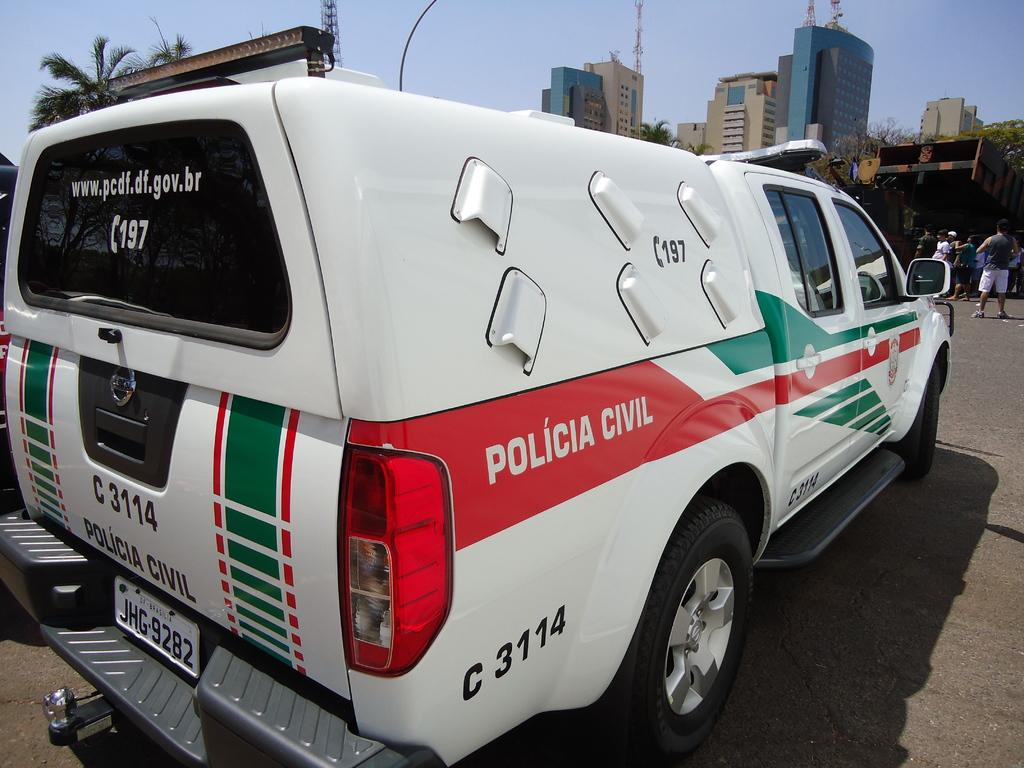<image>
Give a short and clear explanation of the subsequent image. A truck with a cover over the bed that says Policia Civil on it. 